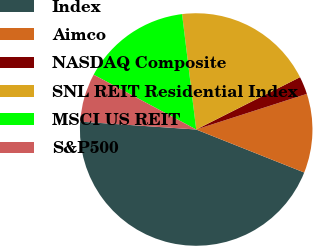Convert chart. <chart><loc_0><loc_0><loc_500><loc_500><pie_chart><fcel>Index<fcel>Aimco<fcel>NASDAQ Composite<fcel>SNL REIT Residential Index<fcel>MSCI US REIT<fcel>S&P500<nl><fcel>45.05%<fcel>10.99%<fcel>2.47%<fcel>19.51%<fcel>15.25%<fcel>6.73%<nl></chart> 